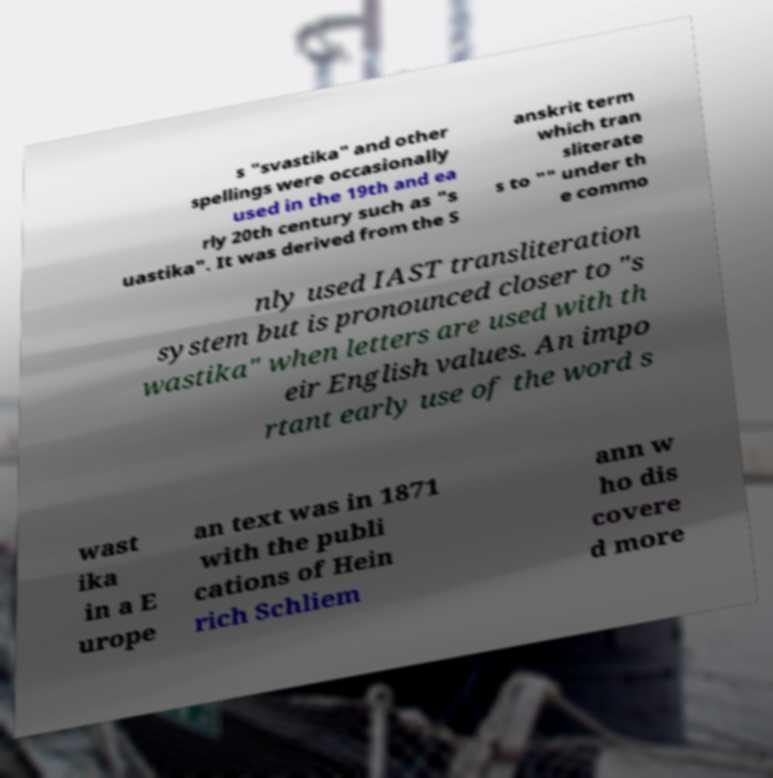Please read and relay the text visible in this image. What does it say? s "svastika" and other spellings were occasionally used in the 19th and ea rly 20th century such as "s uastika". It was derived from the S anskrit term which tran sliterate s to "" under th e commo nly used IAST transliteration system but is pronounced closer to "s wastika" when letters are used with th eir English values. An impo rtant early use of the word s wast ika in a E urope an text was in 1871 with the publi cations of Hein rich Schliem ann w ho dis covere d more 